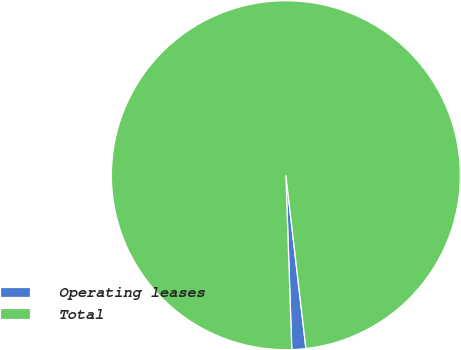Convert chart to OTSL. <chart><loc_0><loc_0><loc_500><loc_500><pie_chart><fcel>Operating leases<fcel>Total<nl><fcel>1.29%<fcel>98.71%<nl></chart> 